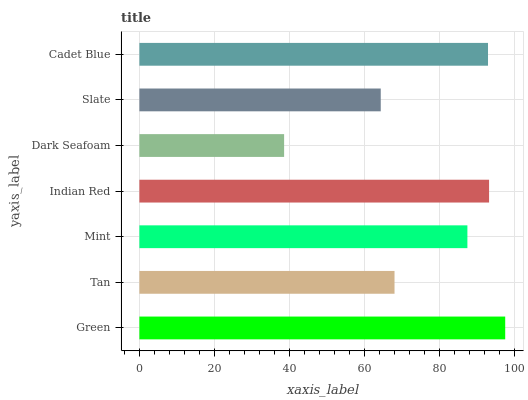Is Dark Seafoam the minimum?
Answer yes or no. Yes. Is Green the maximum?
Answer yes or no. Yes. Is Tan the minimum?
Answer yes or no. No. Is Tan the maximum?
Answer yes or no. No. Is Green greater than Tan?
Answer yes or no. Yes. Is Tan less than Green?
Answer yes or no. Yes. Is Tan greater than Green?
Answer yes or no. No. Is Green less than Tan?
Answer yes or no. No. Is Mint the high median?
Answer yes or no. Yes. Is Mint the low median?
Answer yes or no. Yes. Is Dark Seafoam the high median?
Answer yes or no. No. Is Slate the low median?
Answer yes or no. No. 